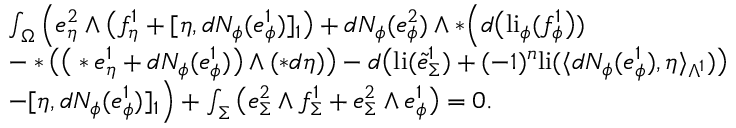<formula> <loc_0><loc_0><loc_500><loc_500>\begin{array} { r l } & { \int _ { \Omega } \Big ( e _ { \eta } ^ { 2 } \wedge \Big ( f _ { \eta } ^ { 1 } + [ \eta , d N _ { \phi } ( e _ { \phi } ^ { 1 } ) ] _ { 1 } \Big ) + d N _ { \phi } ( e _ { \phi } ^ { 2 } ) \wedge \ast \Big ( d \Big ( l i _ { \phi } ( f _ { \phi } ^ { 1 } \Big ) ) } \\ & { - \ast \Big ( \Big ( \ast e _ { \eta } ^ { 1 } + d N _ { \phi } ( e _ { \phi } ^ { 1 } ) \Big ) \wedge ( \ast d \eta ) \Big ) - d \Big ( l i ( \tilde { e } _ { \Sigma } ^ { 1 } ) + ( - 1 ) ^ { n } l i ( \langle d N _ { \phi } ( e _ { \phi } ^ { 1 } ) , \eta \rangle _ { \Lambda ^ { 1 } } ) \Big ) } \\ & { - [ \eta , d N _ { \phi } ( e _ { \phi } ^ { 1 } ) ] _ { 1 } \Big ) + \int _ { \Sigma } \Big ( e _ { \Sigma } ^ { 2 } \wedge f _ { \Sigma } ^ { 1 } + e _ { \Sigma } ^ { 2 } \wedge e _ { \phi } ^ { 1 } \Big ) = 0 . } \end{array}</formula> 